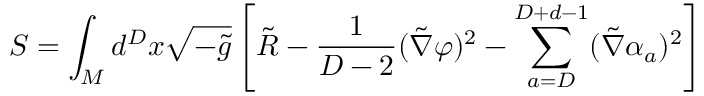Convert formula to latex. <formula><loc_0><loc_0><loc_500><loc_500>S = \int _ { M } d ^ { D } x \sqrt { - \tilde { g } } \left [ \tilde { R } - { \frac { 1 } { D - 2 } } ( \tilde { \nabla } \varphi ) ^ { 2 } - \sum _ { a = D } ^ { D + d - 1 } ( \tilde { \nabla } \alpha _ { a } ) ^ { 2 } \right ]</formula> 